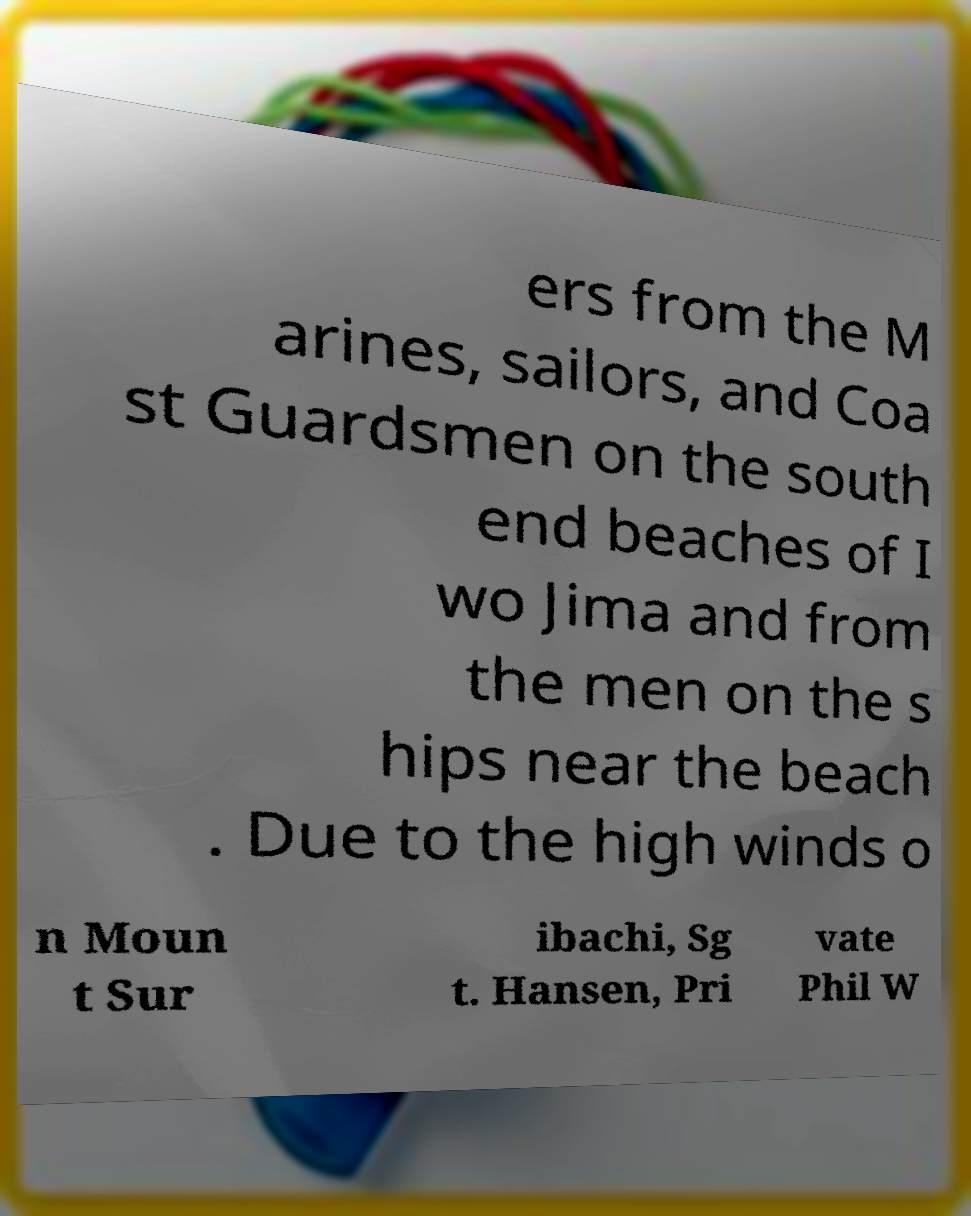What messages or text are displayed in this image? I need them in a readable, typed format. ers from the M arines, sailors, and Coa st Guardsmen on the south end beaches of I wo Jima and from the men on the s hips near the beach . Due to the high winds o n Moun t Sur ibachi, Sg t. Hansen, Pri vate Phil W 